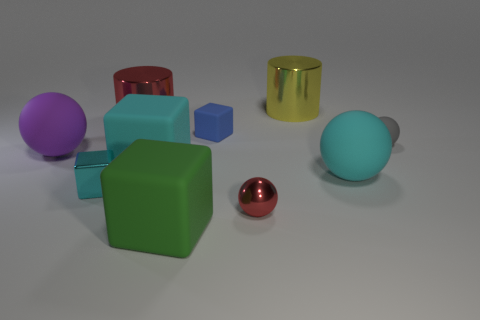Subtract 1 spheres. How many spheres are left? 3 Subtract all cubes. How many objects are left? 6 Add 9 red cylinders. How many red cylinders exist? 10 Subtract 0 brown blocks. How many objects are left? 10 Subtract all large red cylinders. Subtract all metallic blocks. How many objects are left? 8 Add 7 tiny gray things. How many tiny gray things are left? 8 